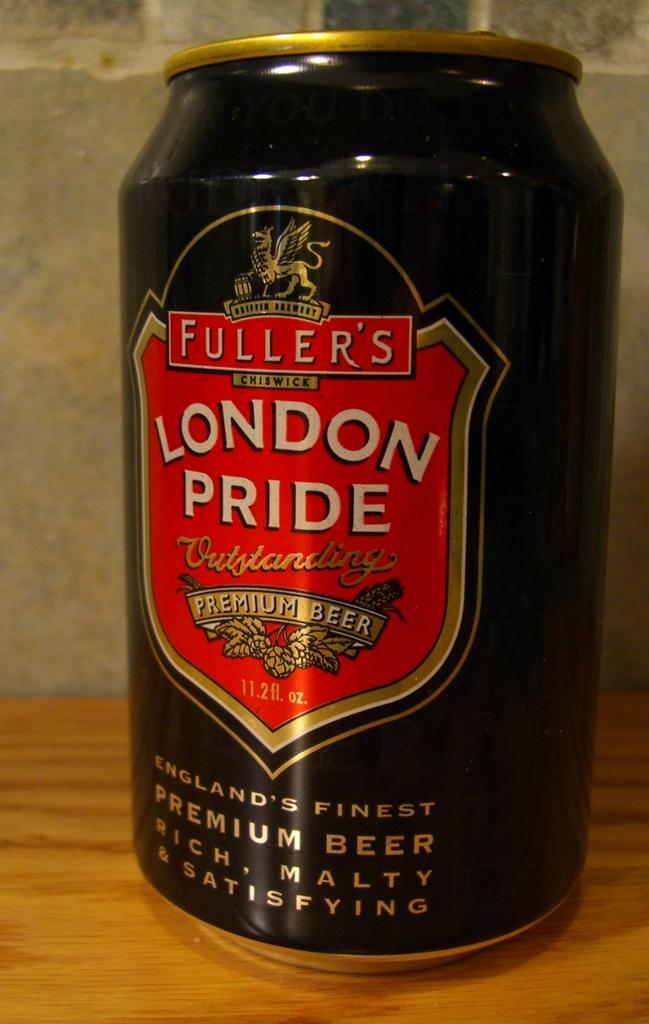In one or two sentences, can you explain what this image depicts? In this image I can see a black color tin and something is written on it. It is on the brown surface. 